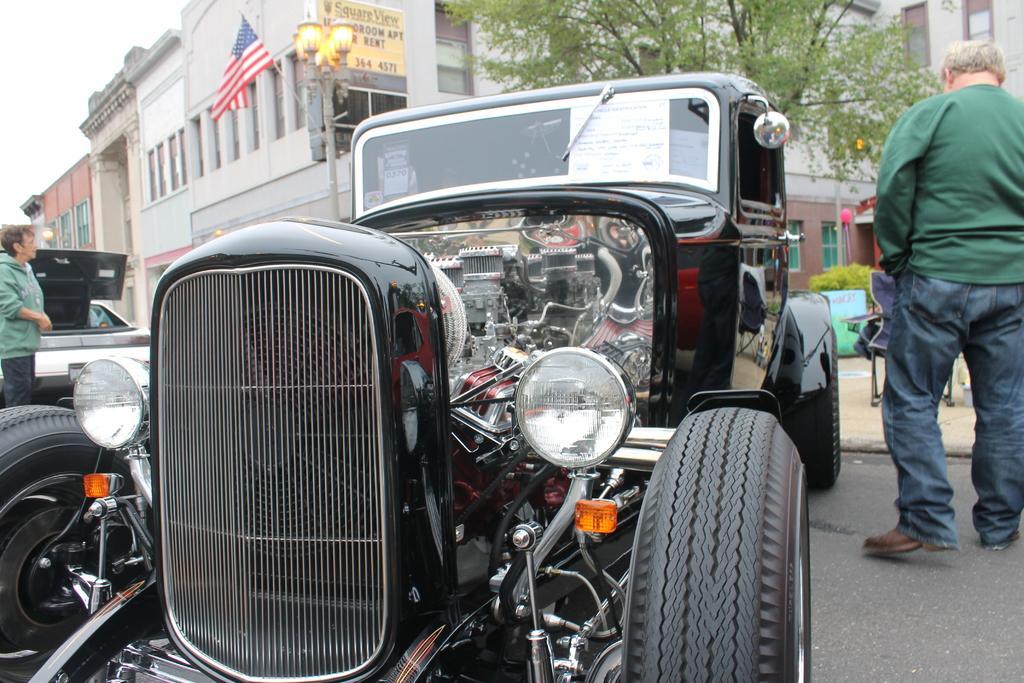How would you summarize this image in a sentence or two? In this image there is a person and vehicle on the left corner. There is a vehicle in the foreground. There is a road at the bottom. There is a person, chair and building on the right corner. There are buildings, a pole with lights, a flag and trees in the background. And there is sky at the top. 